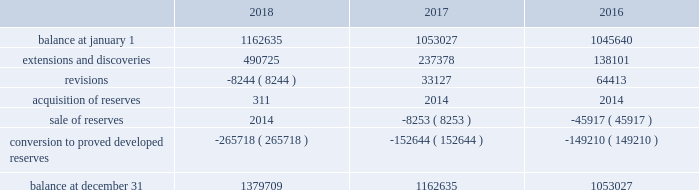Eog resources , inc .
Supplemental information to consolidated financial statements ( continued ) net proved undeveloped reserves .
The table presents the changes in eog's total proved undeveloped reserves during 2018 , 2017 and 2016 ( in mboe ) : .
For the twelve-month period ended december 31 , 2018 , total puds increased by 217 mmboe to 1380 mmboe .
Eog added approximately 31 mmboe of puds through drilling activities where the wells were drilled but significant expenditures remained for completion .
Based on the technology employed by eog to identify and record puds ( see discussion of technology employed on pages f-36 and f-37 of this annual report on form 10-k ) , eog added 460 mmboe .
The pud additions were primarily in the permian basin , anadarko basin , the eagle ford and , to a lesser extent , the rocky mountain area , and 80% ( 80 % ) of the additions were crude oil and condensate and ngls .
During 2018 , eog drilled and transferred 266 mmboe of puds to proved developed reserves at a total capital cost of $ 2745 million .
All puds , including drilled but uncompleted wells ( ducs ) , are scheduled for completion within five years of the original reserve booking .
For the twelve-month period ended december 31 , 2017 , total puds increased by 110 mmboe to 1163 mmboe .
Eog added approximately 38 mmboe of puds through drilling activities where the wells were drilled but significant expenditures remained for completion .
Based on the technology employed by eog to identify and record puds , eog added 199 mmboe .
The pud additions were primarily in the permian basin and , to a lesser extent , the eagle ford and the rocky mountain area , and 74% ( 74 % ) of the additions were crude oil and condensate and ngls .
During 2017 , eog drilled and transferred 153 mmboe of puds to proved developed reserves at a total capital cost of $ 1440 million .
Revisions of puds totaled positive 33 mmboe , primarily due to updated type curves resulting from improved performance of offsetting wells in the permian basin , the impact of increases in the average crude oil and natural gas prices used in the december 31 , 2017 , reserves estimation as compared to the prices used in the prior year estimate , and lower costs .
During 2017 , eog sold or exchanged 8 mmboe of puds primarily in the permian basin .
For the twelve-month period ended december 31 , 2016 , total puds increased by 7 mmboe to 1053 mmboe .
Eog added approximately 21 mmboe of puds through drilling activities where the wells were drilled but significant expenditures remained for completion .
Based on the technology employed by eog to identify and record puds , eog added 117 mmboe .
The pud additions were primarily in the permian basin and , to a lesser extent , the rocky mountain area , and 82% ( 82 % ) of the additions were crude oil and condensate and ngls .
During 2016 , eog drilled and transferred 149 mmboe of puds to proved developed reserves at a total capital cost of $ 1230 million .
Revisions of puds totaled positive 64 mmboe , primarily due to improved well performance , primarily in the delaware basin , and lower production costs , partially offset by the impact of decreases in the average crude oil and natural gas prices used in the december 31 , 2016 , reserves estimation as compared to the prices used in the prior year estimate .
During 2016 , eog sold 46 mmboe of puds primarily in the haynesville play. .
Considering the changes in eog's total proved undeveloped reserves during 2018 , 2017 , and 2016 , what is the average value of extensions and discoveries? 
Rationale: it is the sum of all extensions and discoveries' value divided by three .
Computations: table_average(extensions and discoveries, none)
Answer: 288734.66667. 